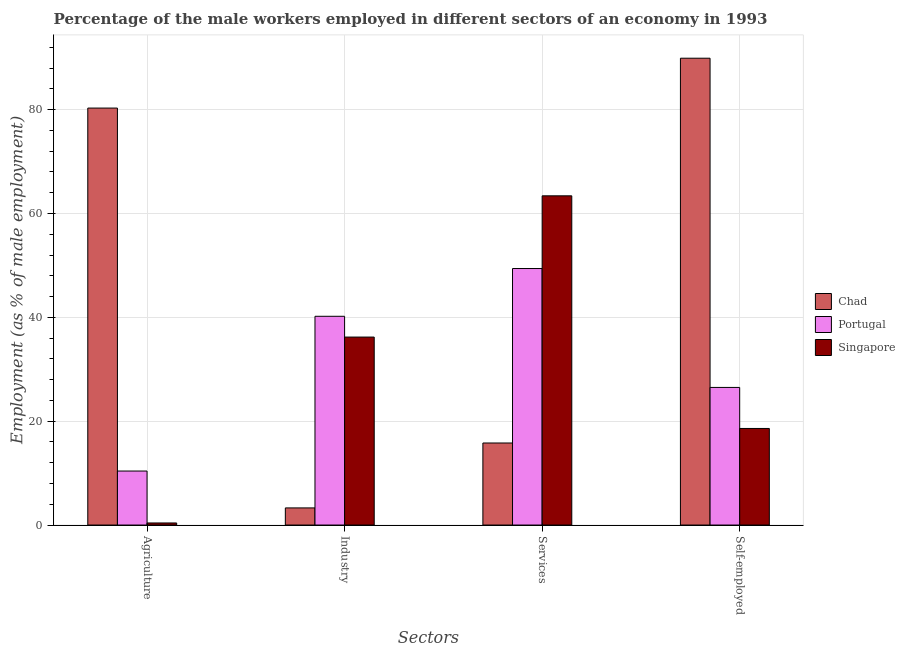Are the number of bars per tick equal to the number of legend labels?
Your answer should be compact. Yes. Are the number of bars on each tick of the X-axis equal?
Make the answer very short. Yes. How many bars are there on the 1st tick from the left?
Keep it short and to the point. 3. How many bars are there on the 4th tick from the right?
Your answer should be very brief. 3. What is the label of the 4th group of bars from the left?
Ensure brevity in your answer.  Self-employed. What is the percentage of male workers in agriculture in Singapore?
Your response must be concise. 0.4. Across all countries, what is the maximum percentage of male workers in industry?
Offer a very short reply. 40.2. Across all countries, what is the minimum percentage of male workers in industry?
Provide a short and direct response. 3.3. In which country was the percentage of male workers in agriculture maximum?
Your response must be concise. Chad. In which country was the percentage of male workers in agriculture minimum?
Keep it short and to the point. Singapore. What is the total percentage of male workers in services in the graph?
Ensure brevity in your answer.  128.6. What is the difference between the percentage of male workers in agriculture in Portugal and that in Chad?
Your answer should be very brief. -69.9. What is the difference between the percentage of male workers in services in Portugal and the percentage of male workers in agriculture in Chad?
Your answer should be compact. -30.9. What is the average percentage of male workers in industry per country?
Your answer should be very brief. 26.57. What is the difference between the percentage of male workers in services and percentage of male workers in agriculture in Chad?
Provide a succinct answer. -64.5. In how many countries, is the percentage of self employed male workers greater than 8 %?
Your answer should be compact. 3. What is the ratio of the percentage of male workers in industry in Chad to that in Singapore?
Your response must be concise. 0.09. Is the difference between the percentage of male workers in industry in Singapore and Portugal greater than the difference between the percentage of self employed male workers in Singapore and Portugal?
Your response must be concise. Yes. What is the difference between the highest and the second highest percentage of self employed male workers?
Make the answer very short. 63.4. What is the difference between the highest and the lowest percentage of male workers in services?
Make the answer very short. 47.6. In how many countries, is the percentage of male workers in agriculture greater than the average percentage of male workers in agriculture taken over all countries?
Make the answer very short. 1. What does the 1st bar from the left in Agriculture represents?
Offer a terse response. Chad. What does the 2nd bar from the right in Self-employed represents?
Make the answer very short. Portugal. Is it the case that in every country, the sum of the percentage of male workers in agriculture and percentage of male workers in industry is greater than the percentage of male workers in services?
Ensure brevity in your answer.  No. How many bars are there?
Ensure brevity in your answer.  12. Are all the bars in the graph horizontal?
Your response must be concise. No. How many countries are there in the graph?
Your answer should be very brief. 3. What is the difference between two consecutive major ticks on the Y-axis?
Make the answer very short. 20. Does the graph contain grids?
Provide a succinct answer. Yes. Where does the legend appear in the graph?
Keep it short and to the point. Center right. How many legend labels are there?
Your answer should be compact. 3. What is the title of the graph?
Offer a very short reply. Percentage of the male workers employed in different sectors of an economy in 1993. What is the label or title of the X-axis?
Ensure brevity in your answer.  Sectors. What is the label or title of the Y-axis?
Provide a succinct answer. Employment (as % of male employment). What is the Employment (as % of male employment) of Chad in Agriculture?
Your answer should be very brief. 80.3. What is the Employment (as % of male employment) of Portugal in Agriculture?
Provide a short and direct response. 10.4. What is the Employment (as % of male employment) of Singapore in Agriculture?
Offer a very short reply. 0.4. What is the Employment (as % of male employment) of Chad in Industry?
Keep it short and to the point. 3.3. What is the Employment (as % of male employment) of Portugal in Industry?
Your answer should be very brief. 40.2. What is the Employment (as % of male employment) of Singapore in Industry?
Your answer should be very brief. 36.2. What is the Employment (as % of male employment) of Chad in Services?
Offer a terse response. 15.8. What is the Employment (as % of male employment) in Portugal in Services?
Provide a succinct answer. 49.4. What is the Employment (as % of male employment) in Singapore in Services?
Provide a short and direct response. 63.4. What is the Employment (as % of male employment) in Chad in Self-employed?
Give a very brief answer. 89.9. What is the Employment (as % of male employment) of Singapore in Self-employed?
Make the answer very short. 18.6. Across all Sectors, what is the maximum Employment (as % of male employment) of Chad?
Keep it short and to the point. 89.9. Across all Sectors, what is the maximum Employment (as % of male employment) of Portugal?
Make the answer very short. 49.4. Across all Sectors, what is the maximum Employment (as % of male employment) in Singapore?
Ensure brevity in your answer.  63.4. Across all Sectors, what is the minimum Employment (as % of male employment) of Chad?
Keep it short and to the point. 3.3. Across all Sectors, what is the minimum Employment (as % of male employment) in Portugal?
Make the answer very short. 10.4. Across all Sectors, what is the minimum Employment (as % of male employment) of Singapore?
Offer a very short reply. 0.4. What is the total Employment (as % of male employment) in Chad in the graph?
Your answer should be compact. 189.3. What is the total Employment (as % of male employment) of Portugal in the graph?
Provide a short and direct response. 126.5. What is the total Employment (as % of male employment) of Singapore in the graph?
Your response must be concise. 118.6. What is the difference between the Employment (as % of male employment) of Portugal in Agriculture and that in Industry?
Ensure brevity in your answer.  -29.8. What is the difference between the Employment (as % of male employment) of Singapore in Agriculture and that in Industry?
Offer a terse response. -35.8. What is the difference between the Employment (as % of male employment) in Chad in Agriculture and that in Services?
Keep it short and to the point. 64.5. What is the difference between the Employment (as % of male employment) in Portugal in Agriculture and that in Services?
Your answer should be very brief. -39. What is the difference between the Employment (as % of male employment) of Singapore in Agriculture and that in Services?
Your answer should be very brief. -63. What is the difference between the Employment (as % of male employment) of Chad in Agriculture and that in Self-employed?
Ensure brevity in your answer.  -9.6. What is the difference between the Employment (as % of male employment) in Portugal in Agriculture and that in Self-employed?
Offer a very short reply. -16.1. What is the difference between the Employment (as % of male employment) in Singapore in Agriculture and that in Self-employed?
Keep it short and to the point. -18.2. What is the difference between the Employment (as % of male employment) in Chad in Industry and that in Services?
Your answer should be compact. -12.5. What is the difference between the Employment (as % of male employment) of Singapore in Industry and that in Services?
Your answer should be compact. -27.2. What is the difference between the Employment (as % of male employment) in Chad in Industry and that in Self-employed?
Your response must be concise. -86.6. What is the difference between the Employment (as % of male employment) of Portugal in Industry and that in Self-employed?
Your answer should be very brief. 13.7. What is the difference between the Employment (as % of male employment) in Singapore in Industry and that in Self-employed?
Keep it short and to the point. 17.6. What is the difference between the Employment (as % of male employment) of Chad in Services and that in Self-employed?
Keep it short and to the point. -74.1. What is the difference between the Employment (as % of male employment) of Portugal in Services and that in Self-employed?
Provide a succinct answer. 22.9. What is the difference between the Employment (as % of male employment) of Singapore in Services and that in Self-employed?
Offer a very short reply. 44.8. What is the difference between the Employment (as % of male employment) of Chad in Agriculture and the Employment (as % of male employment) of Portugal in Industry?
Make the answer very short. 40.1. What is the difference between the Employment (as % of male employment) in Chad in Agriculture and the Employment (as % of male employment) in Singapore in Industry?
Keep it short and to the point. 44.1. What is the difference between the Employment (as % of male employment) in Portugal in Agriculture and the Employment (as % of male employment) in Singapore in Industry?
Your answer should be compact. -25.8. What is the difference between the Employment (as % of male employment) of Chad in Agriculture and the Employment (as % of male employment) of Portugal in Services?
Your answer should be compact. 30.9. What is the difference between the Employment (as % of male employment) in Chad in Agriculture and the Employment (as % of male employment) in Singapore in Services?
Make the answer very short. 16.9. What is the difference between the Employment (as % of male employment) in Portugal in Agriculture and the Employment (as % of male employment) in Singapore in Services?
Provide a succinct answer. -53. What is the difference between the Employment (as % of male employment) in Chad in Agriculture and the Employment (as % of male employment) in Portugal in Self-employed?
Provide a succinct answer. 53.8. What is the difference between the Employment (as % of male employment) of Chad in Agriculture and the Employment (as % of male employment) of Singapore in Self-employed?
Provide a short and direct response. 61.7. What is the difference between the Employment (as % of male employment) in Chad in Industry and the Employment (as % of male employment) in Portugal in Services?
Your response must be concise. -46.1. What is the difference between the Employment (as % of male employment) in Chad in Industry and the Employment (as % of male employment) in Singapore in Services?
Provide a short and direct response. -60.1. What is the difference between the Employment (as % of male employment) of Portugal in Industry and the Employment (as % of male employment) of Singapore in Services?
Offer a very short reply. -23.2. What is the difference between the Employment (as % of male employment) of Chad in Industry and the Employment (as % of male employment) of Portugal in Self-employed?
Give a very brief answer. -23.2. What is the difference between the Employment (as % of male employment) in Chad in Industry and the Employment (as % of male employment) in Singapore in Self-employed?
Your answer should be compact. -15.3. What is the difference between the Employment (as % of male employment) in Portugal in Industry and the Employment (as % of male employment) in Singapore in Self-employed?
Your answer should be very brief. 21.6. What is the difference between the Employment (as % of male employment) in Portugal in Services and the Employment (as % of male employment) in Singapore in Self-employed?
Ensure brevity in your answer.  30.8. What is the average Employment (as % of male employment) of Chad per Sectors?
Offer a terse response. 47.33. What is the average Employment (as % of male employment) of Portugal per Sectors?
Provide a short and direct response. 31.62. What is the average Employment (as % of male employment) in Singapore per Sectors?
Your answer should be very brief. 29.65. What is the difference between the Employment (as % of male employment) of Chad and Employment (as % of male employment) of Portugal in Agriculture?
Provide a succinct answer. 69.9. What is the difference between the Employment (as % of male employment) in Chad and Employment (as % of male employment) in Singapore in Agriculture?
Ensure brevity in your answer.  79.9. What is the difference between the Employment (as % of male employment) of Chad and Employment (as % of male employment) of Portugal in Industry?
Your answer should be very brief. -36.9. What is the difference between the Employment (as % of male employment) in Chad and Employment (as % of male employment) in Singapore in Industry?
Ensure brevity in your answer.  -32.9. What is the difference between the Employment (as % of male employment) in Portugal and Employment (as % of male employment) in Singapore in Industry?
Your answer should be very brief. 4. What is the difference between the Employment (as % of male employment) in Chad and Employment (as % of male employment) in Portugal in Services?
Your answer should be very brief. -33.6. What is the difference between the Employment (as % of male employment) of Chad and Employment (as % of male employment) of Singapore in Services?
Provide a short and direct response. -47.6. What is the difference between the Employment (as % of male employment) in Chad and Employment (as % of male employment) in Portugal in Self-employed?
Offer a terse response. 63.4. What is the difference between the Employment (as % of male employment) of Chad and Employment (as % of male employment) of Singapore in Self-employed?
Give a very brief answer. 71.3. What is the difference between the Employment (as % of male employment) in Portugal and Employment (as % of male employment) in Singapore in Self-employed?
Your answer should be compact. 7.9. What is the ratio of the Employment (as % of male employment) in Chad in Agriculture to that in Industry?
Make the answer very short. 24.33. What is the ratio of the Employment (as % of male employment) of Portugal in Agriculture to that in Industry?
Ensure brevity in your answer.  0.26. What is the ratio of the Employment (as % of male employment) in Singapore in Agriculture to that in Industry?
Offer a very short reply. 0.01. What is the ratio of the Employment (as % of male employment) in Chad in Agriculture to that in Services?
Your answer should be very brief. 5.08. What is the ratio of the Employment (as % of male employment) in Portugal in Agriculture to that in Services?
Provide a short and direct response. 0.21. What is the ratio of the Employment (as % of male employment) in Singapore in Agriculture to that in Services?
Give a very brief answer. 0.01. What is the ratio of the Employment (as % of male employment) of Chad in Agriculture to that in Self-employed?
Provide a short and direct response. 0.89. What is the ratio of the Employment (as % of male employment) of Portugal in Agriculture to that in Self-employed?
Your response must be concise. 0.39. What is the ratio of the Employment (as % of male employment) in Singapore in Agriculture to that in Self-employed?
Provide a short and direct response. 0.02. What is the ratio of the Employment (as % of male employment) of Chad in Industry to that in Services?
Your response must be concise. 0.21. What is the ratio of the Employment (as % of male employment) in Portugal in Industry to that in Services?
Provide a succinct answer. 0.81. What is the ratio of the Employment (as % of male employment) of Singapore in Industry to that in Services?
Ensure brevity in your answer.  0.57. What is the ratio of the Employment (as % of male employment) of Chad in Industry to that in Self-employed?
Your answer should be compact. 0.04. What is the ratio of the Employment (as % of male employment) of Portugal in Industry to that in Self-employed?
Keep it short and to the point. 1.52. What is the ratio of the Employment (as % of male employment) of Singapore in Industry to that in Self-employed?
Offer a terse response. 1.95. What is the ratio of the Employment (as % of male employment) of Chad in Services to that in Self-employed?
Provide a succinct answer. 0.18. What is the ratio of the Employment (as % of male employment) in Portugal in Services to that in Self-employed?
Your answer should be compact. 1.86. What is the ratio of the Employment (as % of male employment) in Singapore in Services to that in Self-employed?
Your answer should be compact. 3.41. What is the difference between the highest and the second highest Employment (as % of male employment) in Singapore?
Provide a short and direct response. 27.2. What is the difference between the highest and the lowest Employment (as % of male employment) in Chad?
Your answer should be compact. 86.6. 